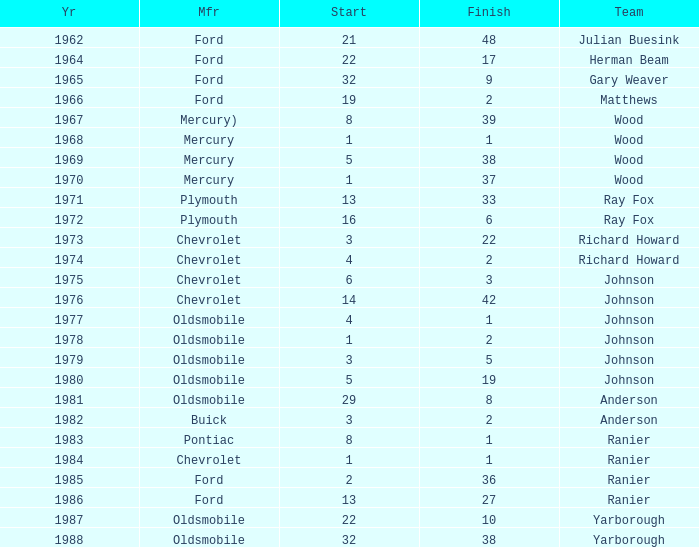What is the smallest finish time for a race after 1972 with a car manufactured by pontiac? 1.0. 